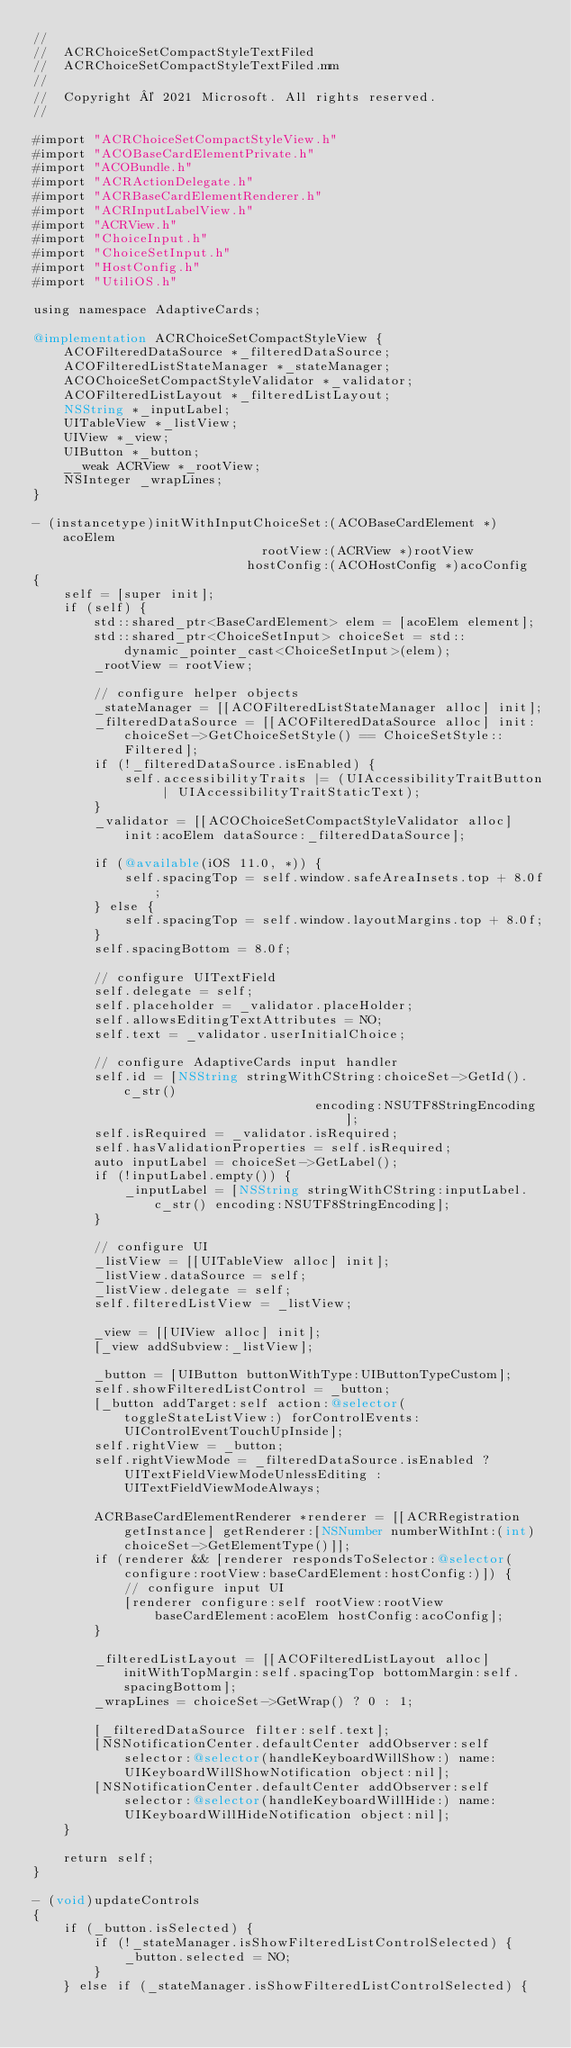<code> <loc_0><loc_0><loc_500><loc_500><_ObjectiveC_>//
//  ACRChoiceSetCompactStyleTextFiled
//  ACRChoiceSetCompactStyleTextFiled.mm
//
//  Copyright © 2021 Microsoft. All rights reserved.
//

#import "ACRChoiceSetCompactStyleView.h"
#import "ACOBaseCardElementPrivate.h"
#import "ACOBundle.h"
#import "ACRActionDelegate.h"
#import "ACRBaseCardElementRenderer.h"
#import "ACRInputLabelView.h"
#import "ACRView.h"
#import "ChoiceInput.h"
#import "ChoiceSetInput.h"
#import "HostConfig.h"
#import "UtiliOS.h"

using namespace AdaptiveCards;

@implementation ACRChoiceSetCompactStyleView {
    ACOFilteredDataSource *_filteredDataSource;
    ACOFilteredListStateManager *_stateManager;
    ACOChoiceSetCompactStyleValidator *_validator;
    ACOFilteredListLayout *_filteredListLayout;
    NSString *_inputLabel;
    UITableView *_listView;
    UIView *_view;
    UIButton *_button;
    __weak ACRView *_rootView;
    NSInteger _wrapLines;
}

- (instancetype)initWithInputChoiceSet:(ACOBaseCardElement *)acoElem
                              rootView:(ACRView *)rootView
                            hostConfig:(ACOHostConfig *)acoConfig
{
    self = [super init];
    if (self) {
        std::shared_ptr<BaseCardElement> elem = [acoElem element];
        std::shared_ptr<ChoiceSetInput> choiceSet = std::dynamic_pointer_cast<ChoiceSetInput>(elem);
        _rootView = rootView;

        // configure helper objects
        _stateManager = [[ACOFilteredListStateManager alloc] init];
        _filteredDataSource = [[ACOFilteredDataSource alloc] init:choiceSet->GetChoiceSetStyle() == ChoiceSetStyle::Filtered];
        if (!_filteredDataSource.isEnabled) {
            self.accessibilityTraits |= (UIAccessibilityTraitButton | UIAccessibilityTraitStaticText);
        }
        _validator = [[ACOChoiceSetCompactStyleValidator alloc] init:acoElem dataSource:_filteredDataSource];

        if (@available(iOS 11.0, *)) {
            self.spacingTop = self.window.safeAreaInsets.top + 8.0f;
        } else {
            self.spacingTop = self.window.layoutMargins.top + 8.0f;
        }
        self.spacingBottom = 8.0f;

        // configure UITextField
        self.delegate = self;
        self.placeholder = _validator.placeHolder;
        self.allowsEditingTextAttributes = NO;
        self.text = _validator.userInitialChoice;

        // configure AdaptiveCards input handler
        self.id = [NSString stringWithCString:choiceSet->GetId().c_str()
                                     encoding:NSUTF8StringEncoding];
        self.isRequired = _validator.isRequired;
        self.hasValidationProperties = self.isRequired;
        auto inputLabel = choiceSet->GetLabel();
        if (!inputLabel.empty()) {
            _inputLabel = [NSString stringWithCString:inputLabel.c_str() encoding:NSUTF8StringEncoding];
        }

        // configure UI
        _listView = [[UITableView alloc] init];
        _listView.dataSource = self;
        _listView.delegate = self;
        self.filteredListView = _listView;

        _view = [[UIView alloc] init];
        [_view addSubview:_listView];

        _button = [UIButton buttonWithType:UIButtonTypeCustom];
        self.showFilteredListControl = _button;
        [_button addTarget:self action:@selector(toggleStateListView:) forControlEvents:UIControlEventTouchUpInside];
        self.rightView = _button;
        self.rightViewMode = _filteredDataSource.isEnabled ? UITextFieldViewModeUnlessEditing : UITextFieldViewModeAlways;

        ACRBaseCardElementRenderer *renderer = [[ACRRegistration getInstance] getRenderer:[NSNumber numberWithInt:(int)choiceSet->GetElementType()]];
        if (renderer && [renderer respondsToSelector:@selector(configure:rootView:baseCardElement:hostConfig:)]) {
            // configure input UI
            [renderer configure:self rootView:rootView baseCardElement:acoElem hostConfig:acoConfig];
        }

        _filteredListLayout = [[ACOFilteredListLayout alloc] initWithTopMargin:self.spacingTop bottomMargin:self.spacingBottom];
        _wrapLines = choiceSet->GetWrap() ? 0 : 1;

        [_filteredDataSource filter:self.text];
        [NSNotificationCenter.defaultCenter addObserver:self selector:@selector(handleKeyboardWillShow:) name:UIKeyboardWillShowNotification object:nil];
        [NSNotificationCenter.defaultCenter addObserver:self selector:@selector(handleKeyboardWillHide:) name:UIKeyboardWillHideNotification object:nil];
    }

    return self;
}

- (void)updateControls
{
    if (_button.isSelected) {
        if (!_stateManager.isShowFilteredListControlSelected) {
            _button.selected = NO;
        }
    } else if (_stateManager.isShowFilteredListControlSelected) {</code> 